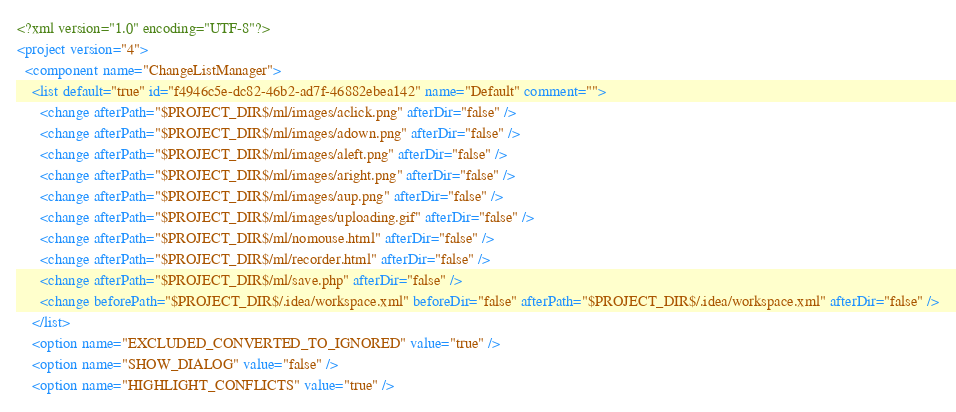Convert code to text. <code><loc_0><loc_0><loc_500><loc_500><_XML_><?xml version="1.0" encoding="UTF-8"?>
<project version="4">
  <component name="ChangeListManager">
    <list default="true" id="f4946c5e-dc82-46b2-ad7f-46882ebea142" name="Default" comment="">
      <change afterPath="$PROJECT_DIR$/ml/images/aclick.png" afterDir="false" />
      <change afterPath="$PROJECT_DIR$/ml/images/adown.png" afterDir="false" />
      <change afterPath="$PROJECT_DIR$/ml/images/aleft.png" afterDir="false" />
      <change afterPath="$PROJECT_DIR$/ml/images/aright.png" afterDir="false" />
      <change afterPath="$PROJECT_DIR$/ml/images/aup.png" afterDir="false" />
      <change afterPath="$PROJECT_DIR$/ml/images/uploading.gif" afterDir="false" />
      <change afterPath="$PROJECT_DIR$/ml/nomouse.html" afterDir="false" />
      <change afterPath="$PROJECT_DIR$/ml/recorder.html" afterDir="false" />
      <change afterPath="$PROJECT_DIR$/ml/save.php" afterDir="false" />
      <change beforePath="$PROJECT_DIR$/.idea/workspace.xml" beforeDir="false" afterPath="$PROJECT_DIR$/.idea/workspace.xml" afterDir="false" />
    </list>
    <option name="EXCLUDED_CONVERTED_TO_IGNORED" value="true" />
    <option name="SHOW_DIALOG" value="false" />
    <option name="HIGHLIGHT_CONFLICTS" value="true" /></code> 